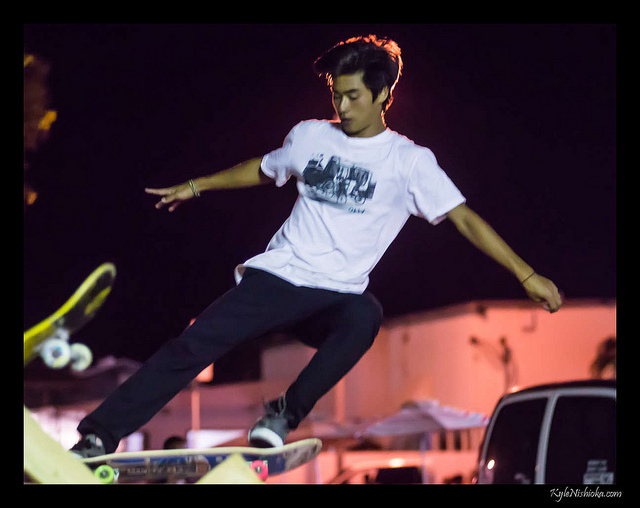Extract all visible text content from this image. KyleNishioka.com 